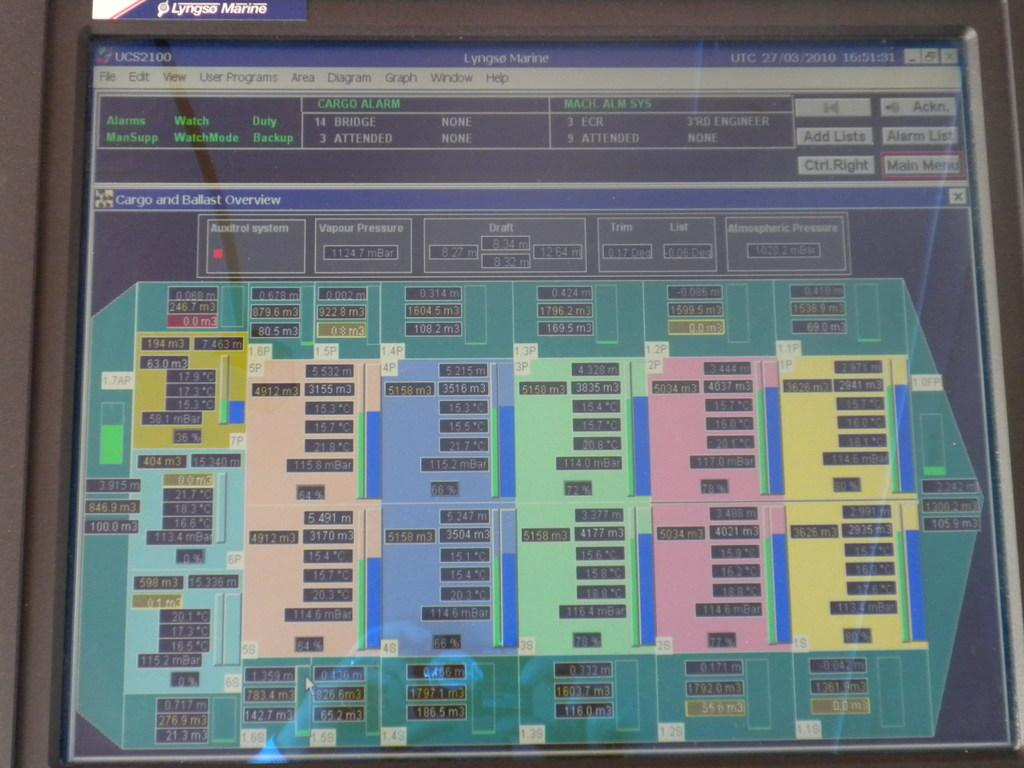<image>
Offer a succinct explanation of the picture presented. A Lyngse Marine Computer has a table with many numbers on the screen 